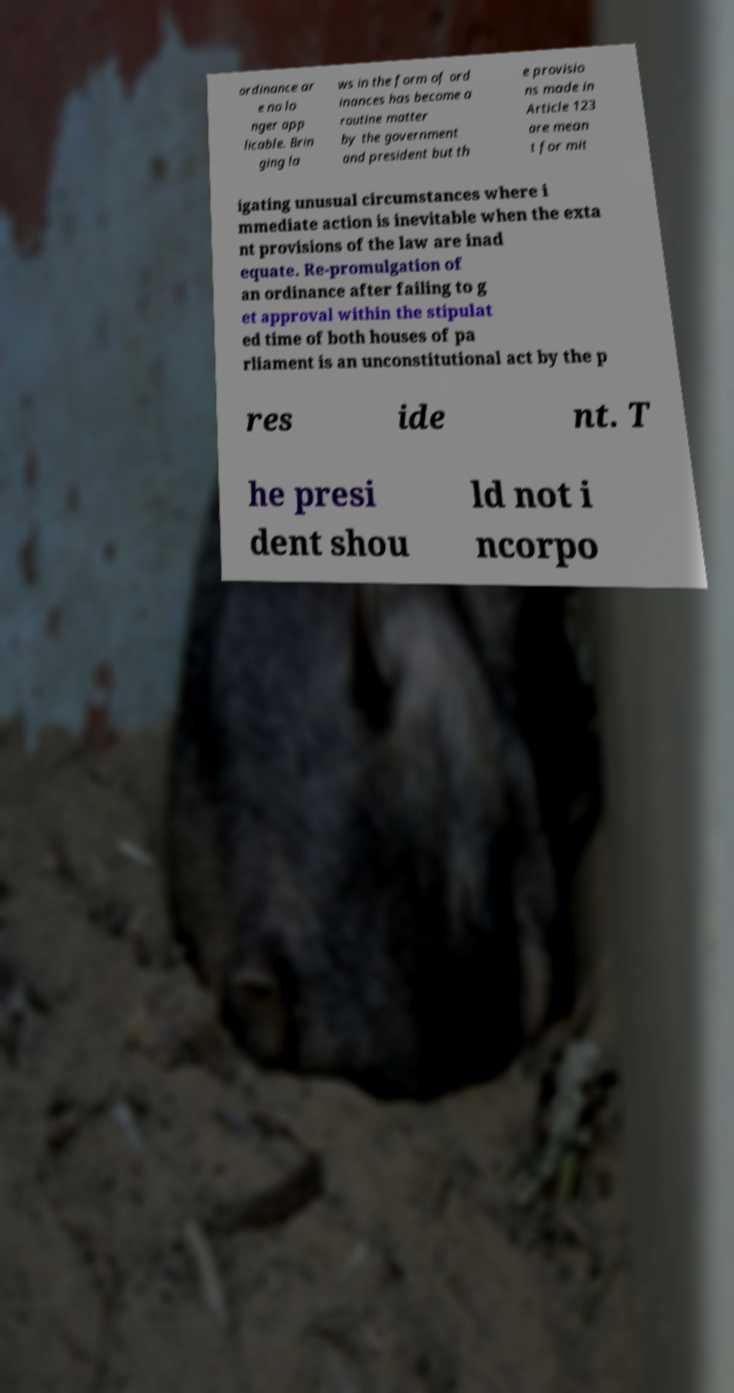Could you extract and type out the text from this image? ordinance ar e no lo nger app licable. Brin ging la ws in the form of ord inances has become a routine matter by the government and president but th e provisio ns made in Article 123 are mean t for mit igating unusual circumstances where i mmediate action is inevitable when the exta nt provisions of the law are inad equate. Re-promulgation of an ordinance after failing to g et approval within the stipulat ed time of both houses of pa rliament is an unconstitutional act by the p res ide nt. T he presi dent shou ld not i ncorpo 